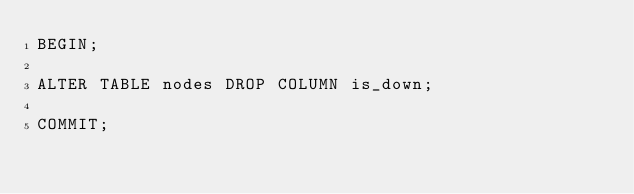<code> <loc_0><loc_0><loc_500><loc_500><_SQL_>BEGIN;

ALTER TABLE nodes DROP COLUMN is_down;

COMMIT;
</code> 